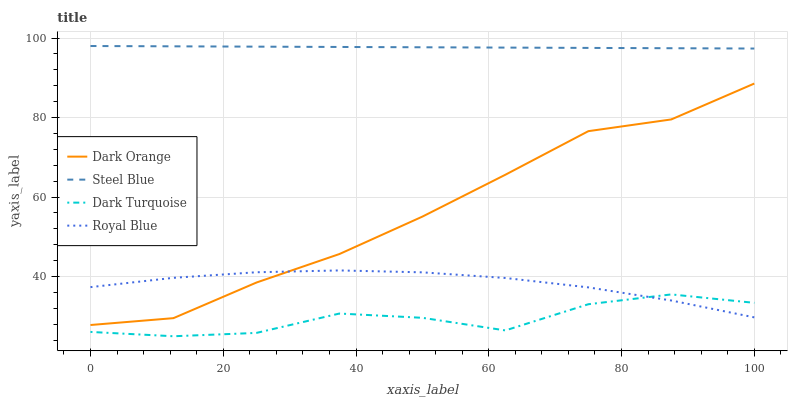Does Royal Blue have the minimum area under the curve?
Answer yes or no. No. Does Royal Blue have the maximum area under the curve?
Answer yes or no. No. Is Royal Blue the smoothest?
Answer yes or no. No. Is Royal Blue the roughest?
Answer yes or no. No. Does Royal Blue have the lowest value?
Answer yes or no. No. Does Royal Blue have the highest value?
Answer yes or no. No. Is Royal Blue less than Steel Blue?
Answer yes or no. Yes. Is Dark Orange greater than Dark Turquoise?
Answer yes or no. Yes. Does Royal Blue intersect Steel Blue?
Answer yes or no. No. 